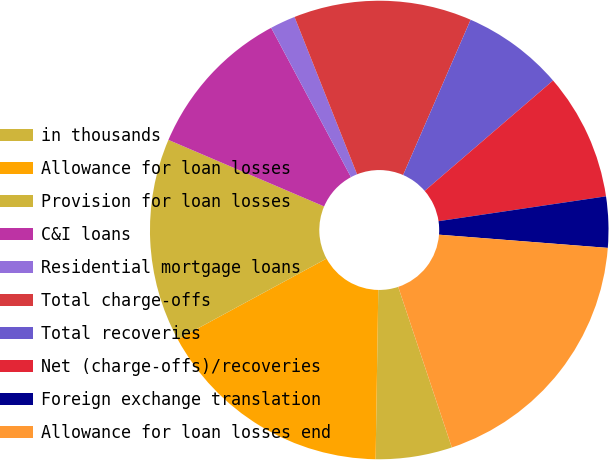Convert chart. <chart><loc_0><loc_0><loc_500><loc_500><pie_chart><fcel>in thousands<fcel>Allowance for loan losses<fcel>Provision for loan losses<fcel>C&I loans<fcel>Residential mortgage loans<fcel>Total charge-offs<fcel>Total recoveries<fcel>Net (charge-offs)/recoveries<fcel>Foreign exchange translation<fcel>Allowance for loan losses end<nl><fcel>5.38%<fcel>16.84%<fcel>14.34%<fcel>10.76%<fcel>1.79%<fcel>12.55%<fcel>7.17%<fcel>8.96%<fcel>3.59%<fcel>18.63%<nl></chart> 